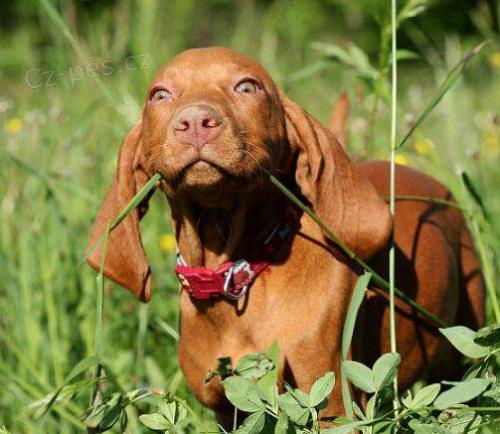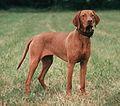The first image is the image on the left, the second image is the image on the right. For the images displayed, is the sentence "One of the images shows a brown dog with one of its front legs raised and the other image shows a brown dog standing in grass." factually correct? Answer yes or no. No. The first image is the image on the left, the second image is the image on the right. Given the left and right images, does the statement "One dog has it's front leg up and bent in a pose." hold true? Answer yes or no. No. 